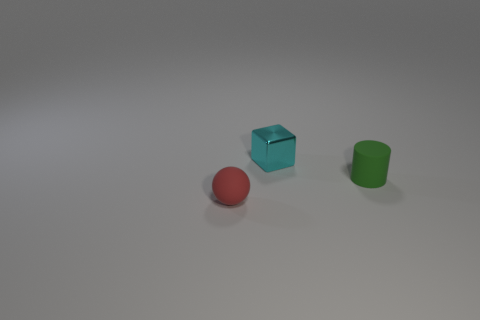Add 3 red rubber objects. How many objects exist? 6 Subtract all cylinders. How many objects are left? 2 Subtract 1 cylinders. How many cylinders are left? 0 Subtract all yellow metallic cylinders. Subtract all green matte cylinders. How many objects are left? 2 Add 2 tiny matte spheres. How many tiny matte spheres are left? 3 Add 3 large yellow metallic cylinders. How many large yellow metallic cylinders exist? 3 Subtract 0 cyan cylinders. How many objects are left? 3 Subtract all gray blocks. Subtract all red balls. How many blocks are left? 1 